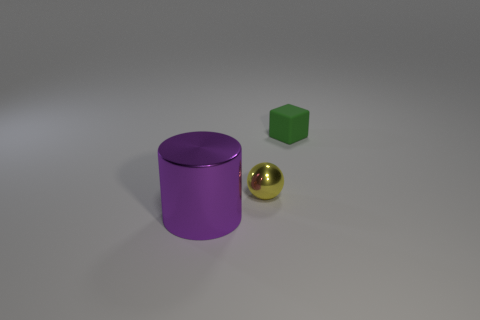Add 2 purple shiny cylinders. How many objects exist? 5 Subtract all blocks. How many objects are left? 2 Subtract all small brown matte things. Subtract all large metallic things. How many objects are left? 2 Add 3 tiny metallic objects. How many tiny metallic objects are left? 4 Add 1 tiny green matte blocks. How many tiny green matte blocks exist? 2 Subtract 0 cyan cylinders. How many objects are left? 3 